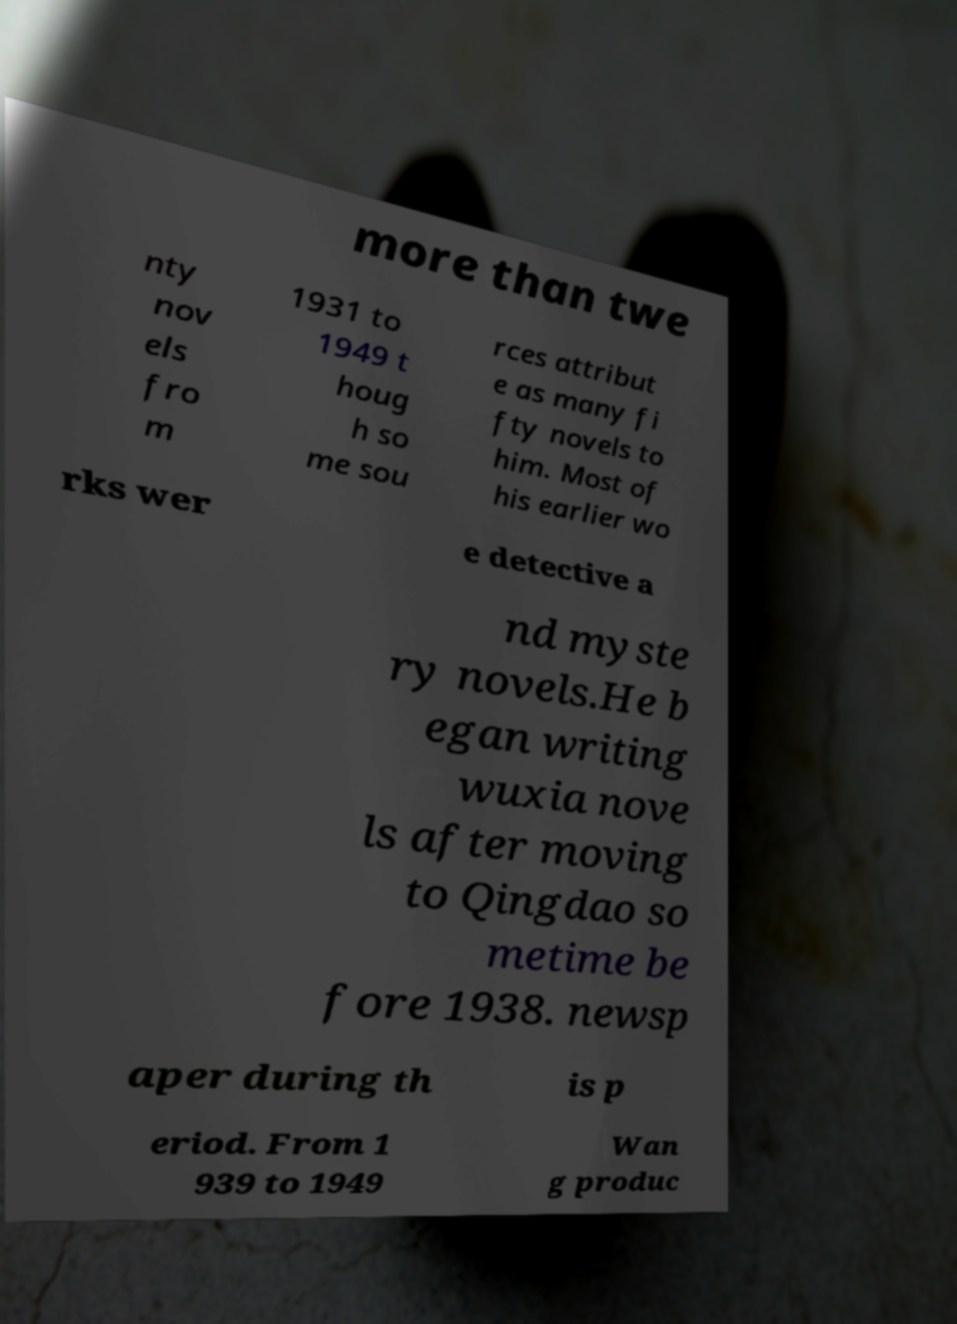Please read and relay the text visible in this image. What does it say? more than twe nty nov els fro m 1931 to 1949 t houg h so me sou rces attribut e as many fi fty novels to him. Most of his earlier wo rks wer e detective a nd myste ry novels.He b egan writing wuxia nove ls after moving to Qingdao so metime be fore 1938. newsp aper during th is p eriod. From 1 939 to 1949 Wan g produc 